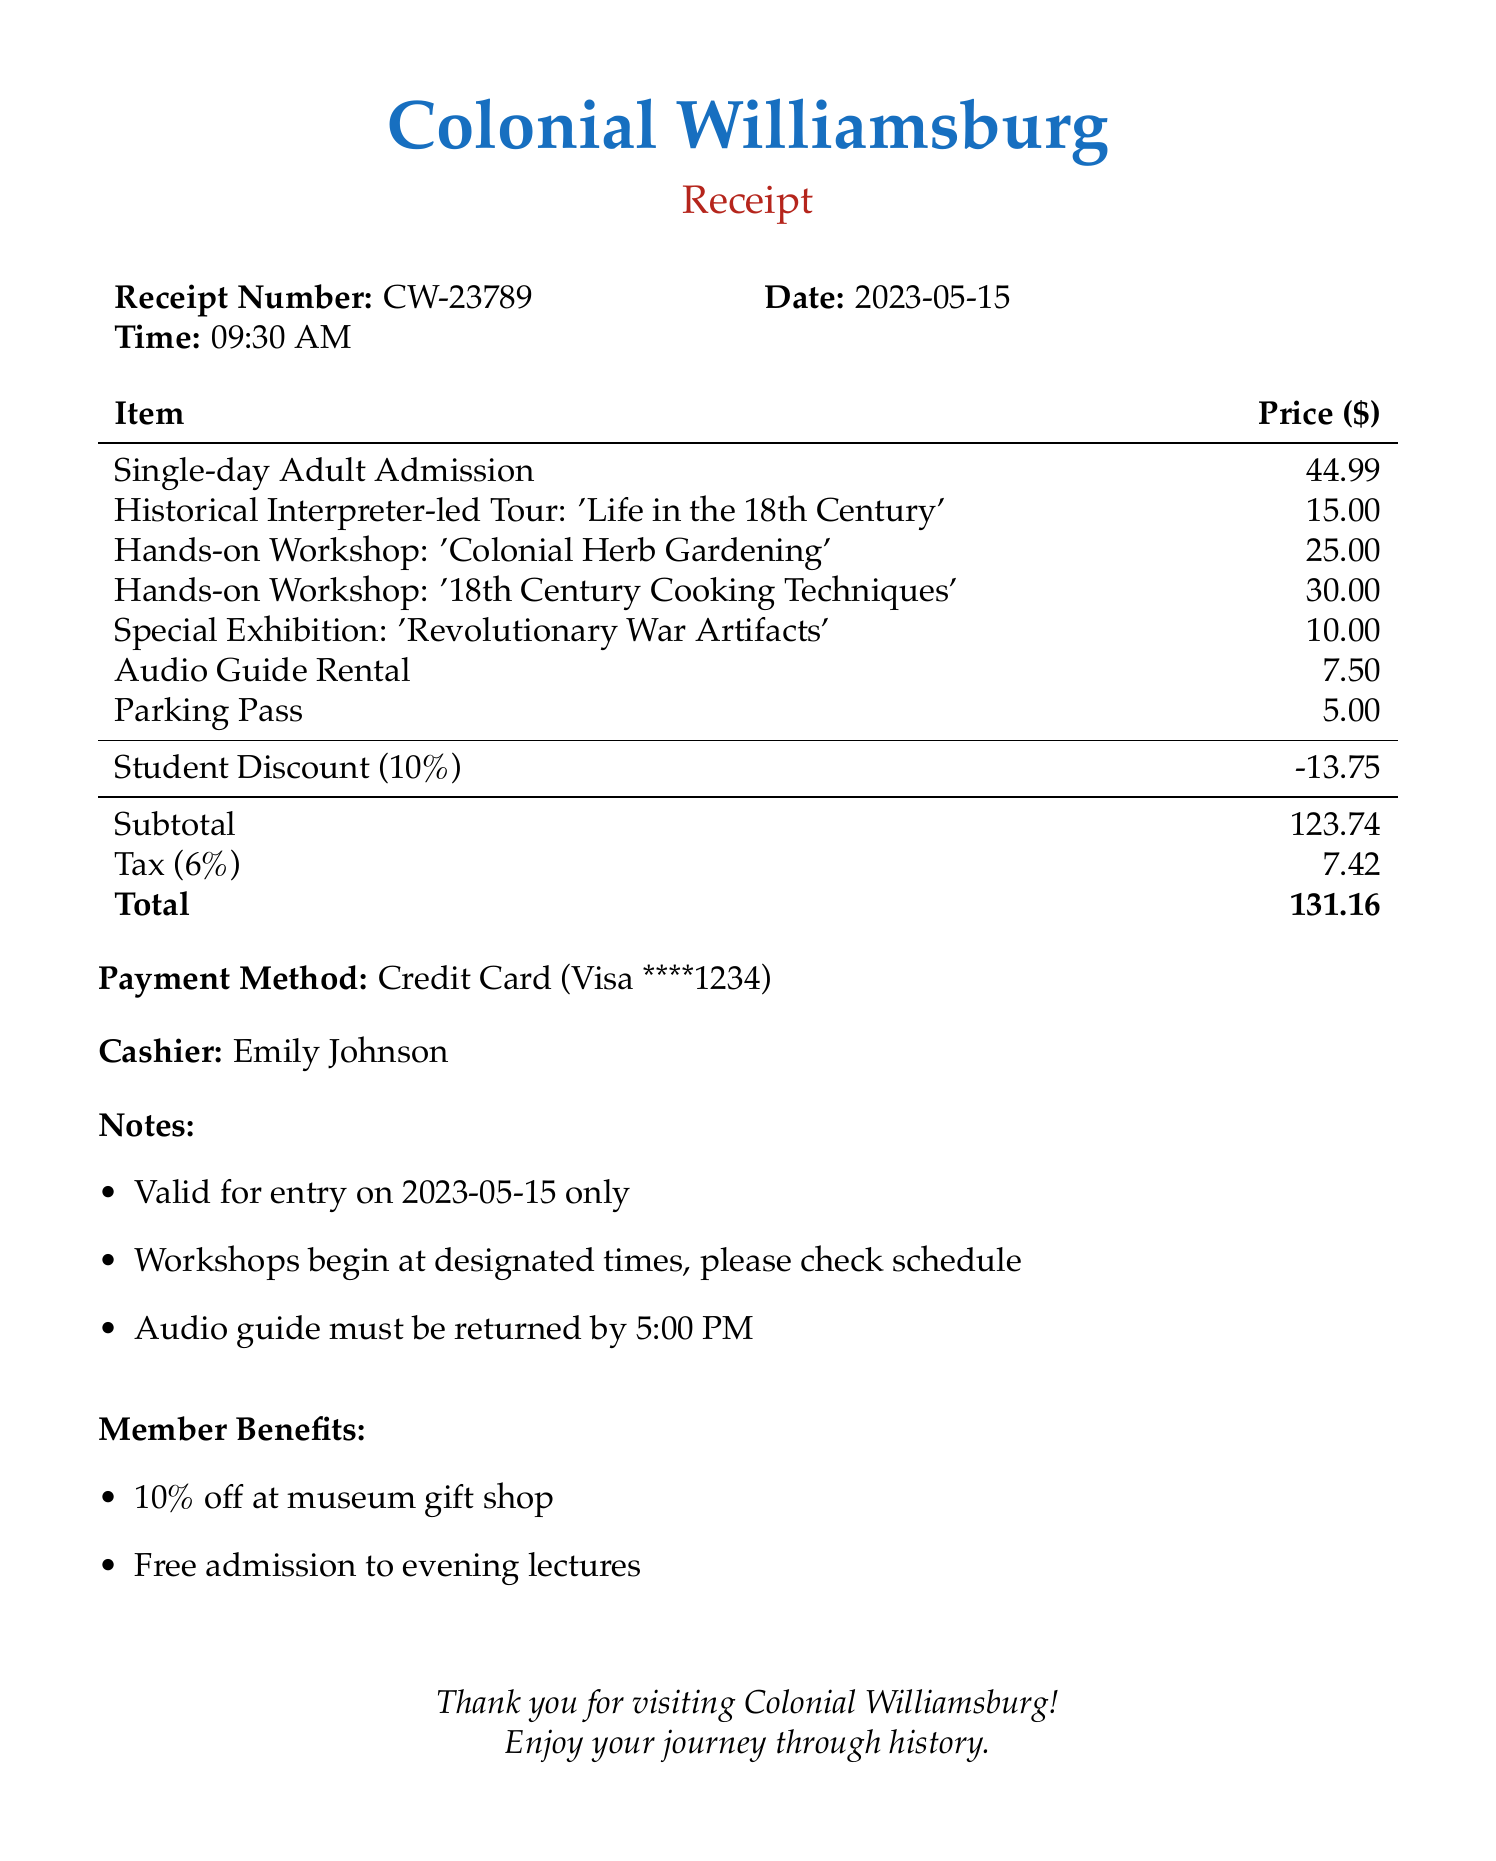what is the name of the museum? The name of the museum is located at the top of the receipt, indicating where the admission was purchased.
Answer: Colonial Williamsburg what is the receipt number? The receipt number is provided under the museum name and indicates the specific transaction.
Answer: CW-23789 what is the total amount after tax? The total amount after tax is calculated at the end of the receipt, summarizing the overall cost of the admission and services.
Answer: 131.16 how much does the 'Historical Interpreter-led Tour' cost? The cost of the tour is listed among the admission items with its corresponding price.
Answer: 15.00 what discount is applied on the receipt? The discount is detailed under discounts, indicating any savings applied to the overall cost.
Answer: Student Discount (10%) how many hands-on workshops are included in the receipt? The number of workshops can be identified by counting the relevant entries in the admission item list.
Answer: 2 what is the tax rate applied? The tax rate is indicated in the receipt, showing the percentage used to calculate the tax amount.
Answer: 6% who is the cashier? The name of the cashier is presented towards the end of the receipt, confirming the staff member handling the transaction.
Answer: Emily Johnson when is the audio guide due for return? The due time for returning the audio guide is mentioned in the notes section of the receipt.
Answer: 5:00 PM 